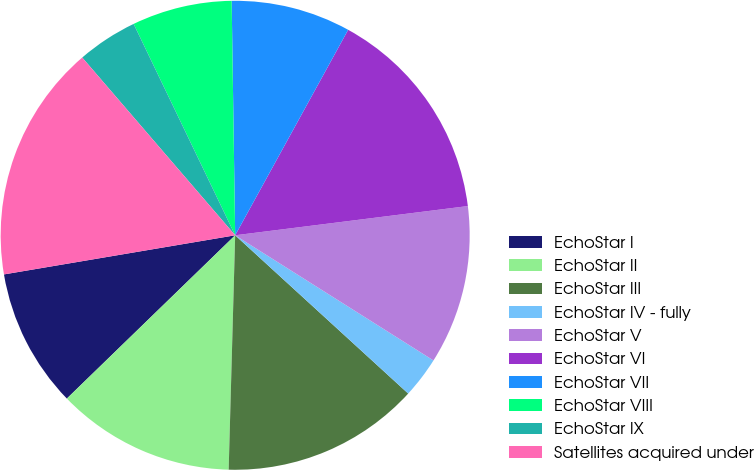Convert chart to OTSL. <chart><loc_0><loc_0><loc_500><loc_500><pie_chart><fcel>EchoStar I<fcel>EchoStar II<fcel>EchoStar III<fcel>EchoStar IV - fully<fcel>EchoStar V<fcel>EchoStar VI<fcel>EchoStar VII<fcel>EchoStar VIII<fcel>EchoStar IX<fcel>Satellites acquired under<nl><fcel>9.59%<fcel>12.3%<fcel>13.65%<fcel>2.83%<fcel>10.95%<fcel>15.01%<fcel>8.24%<fcel>6.89%<fcel>4.18%<fcel>16.36%<nl></chart> 